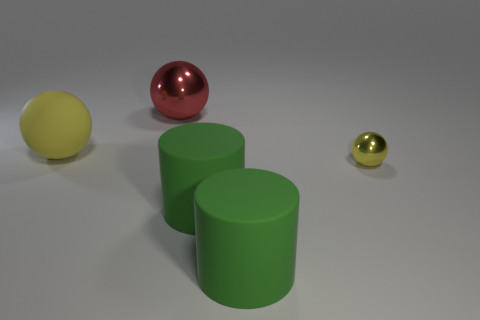Add 4 big spheres. How many objects exist? 9 Subtract all cylinders. How many objects are left? 3 Subtract 1 red spheres. How many objects are left? 4 Subtract all brown matte cubes. Subtract all large matte objects. How many objects are left? 2 Add 5 big red things. How many big red things are left? 6 Add 1 small red metal cylinders. How many small red metal cylinders exist? 1 